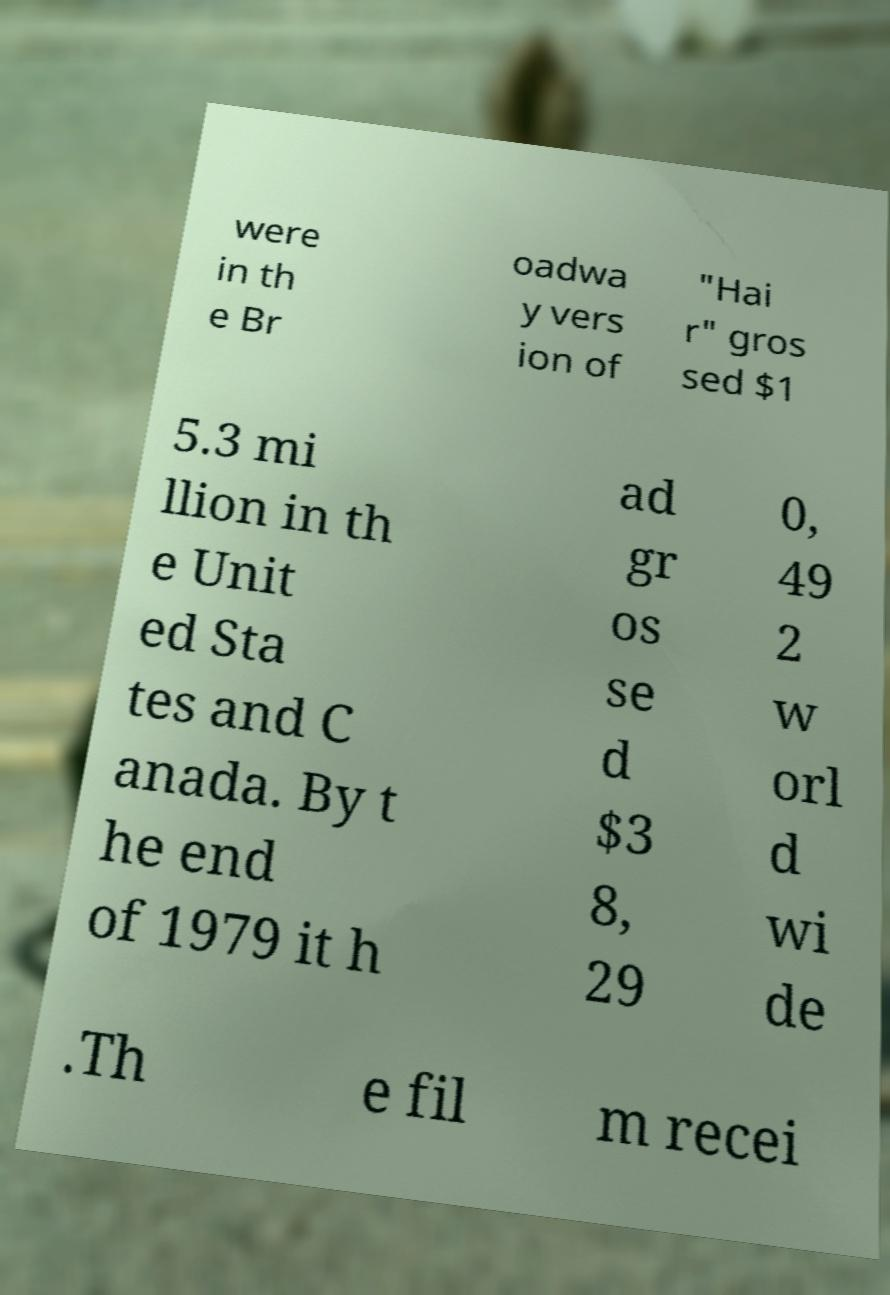Please identify and transcribe the text found in this image. were in th e Br oadwa y vers ion of "Hai r" gros sed $1 5.3 mi llion in th e Unit ed Sta tes and C anada. By t he end of 1979 it h ad gr os se d $3 8, 29 0, 49 2 w orl d wi de .Th e fil m recei 